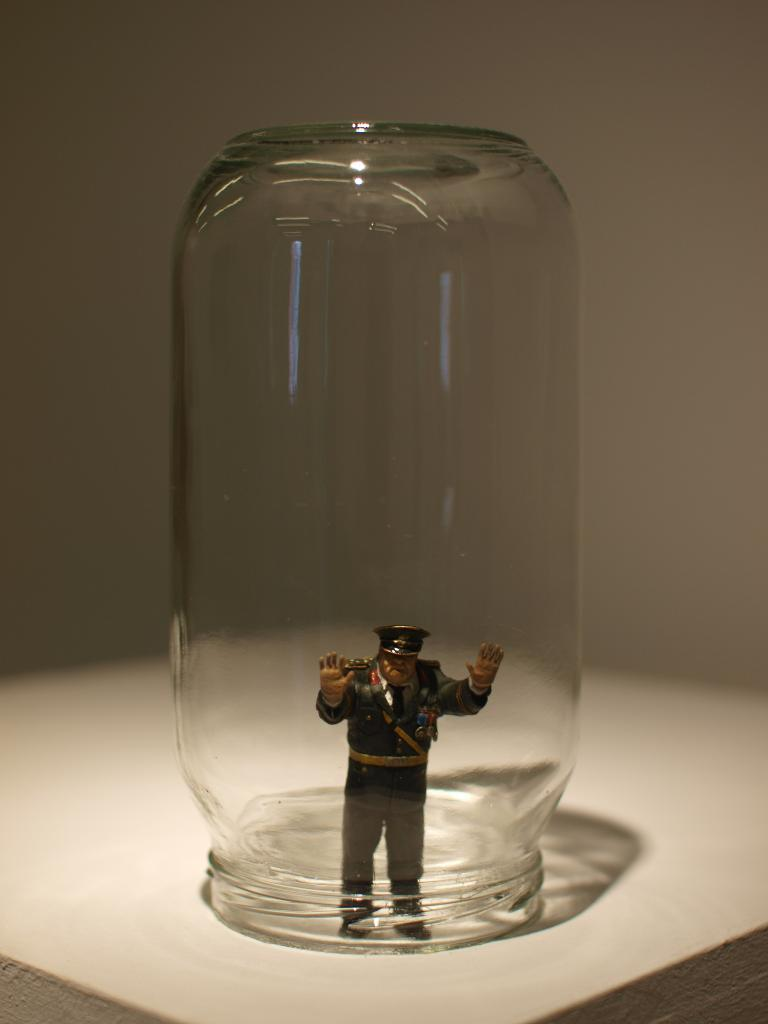What object can be seen in the image? There is a toy in the image. Where is the toy located? The toy is inside a bottle. Can you describe the position of the bottle in the image? The bottle is on a table. What type of voice can be heard coming from the toy in the image? There is no indication in the image that the toy has a voice or makes any sounds. 